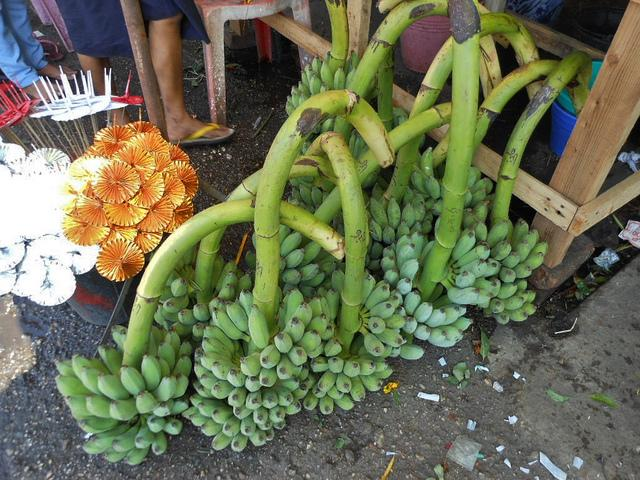What is the brown post behind the green fruit made of? Please explain your reasoning. wood. The post is wood. 